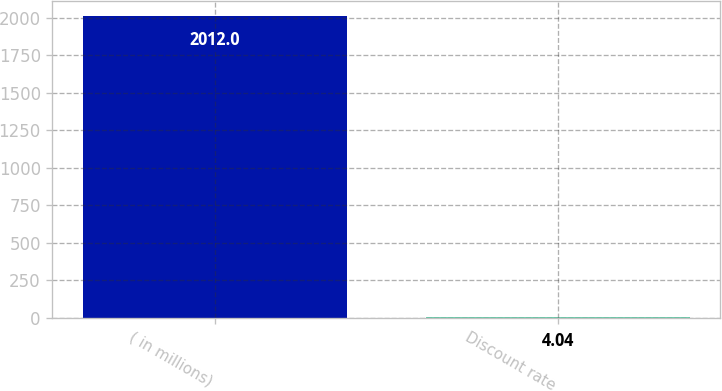<chart> <loc_0><loc_0><loc_500><loc_500><bar_chart><fcel>( in millions)<fcel>Discount rate<nl><fcel>2012<fcel>4.04<nl></chart> 